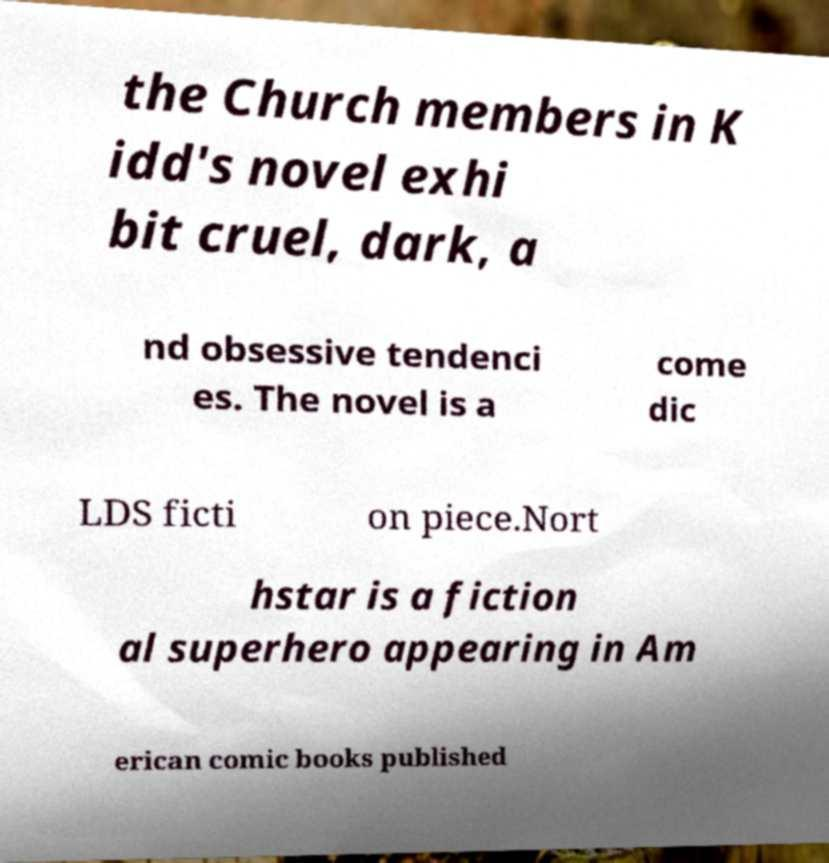Can you read and provide the text displayed in the image?This photo seems to have some interesting text. Can you extract and type it out for me? the Church members in K idd's novel exhi bit cruel, dark, a nd obsessive tendenci es. The novel is a come dic LDS ficti on piece.Nort hstar is a fiction al superhero appearing in Am erican comic books published 